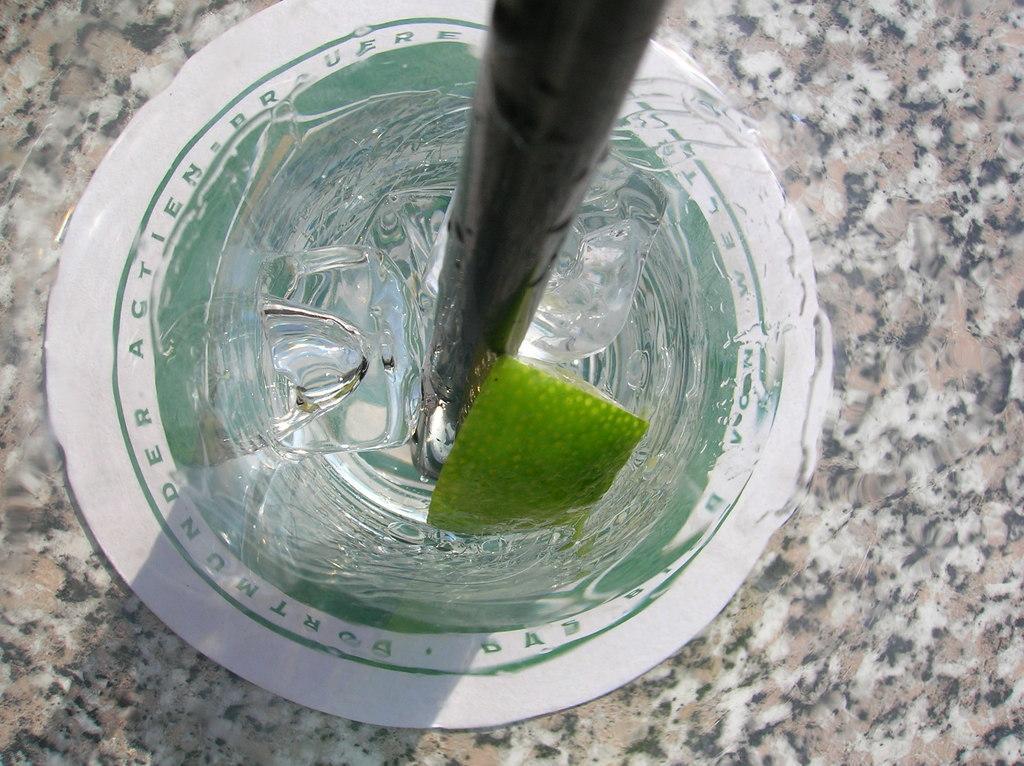Can you describe this image briefly? In this picture I can see ice cubes, a piece of lemon and wooden object. I can see marble surface. 